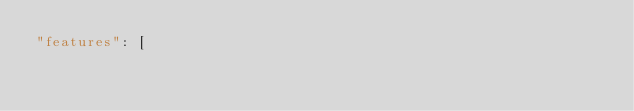Convert code to text. <code><loc_0><loc_0><loc_500><loc_500><_JavaScript_>"features": [</code> 